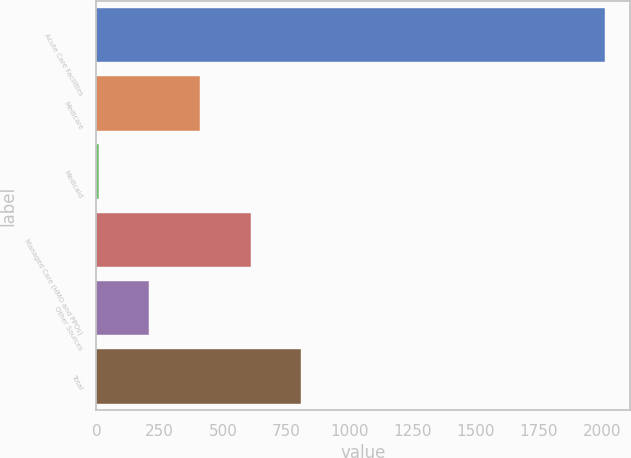Convert chart. <chart><loc_0><loc_0><loc_500><loc_500><bar_chart><fcel>Acute Care Facilities<fcel>Medicare<fcel>Medicaid<fcel>Managed Care (HMO and PPOs)<fcel>Other Sources<fcel>Total<nl><fcel>2009<fcel>409.8<fcel>10<fcel>609.7<fcel>209.9<fcel>809.6<nl></chart> 